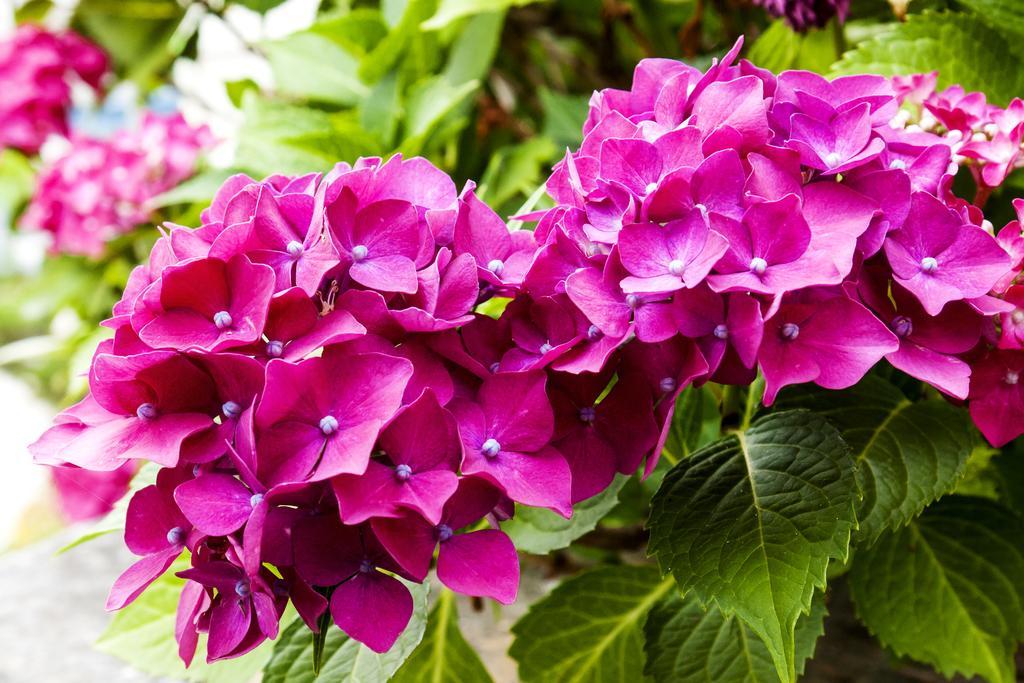Could you give a brief overview of what you see in this image? In this image I can see few flowers which are pink and white in color to the plant which is green in color. I can see the blurry background. 